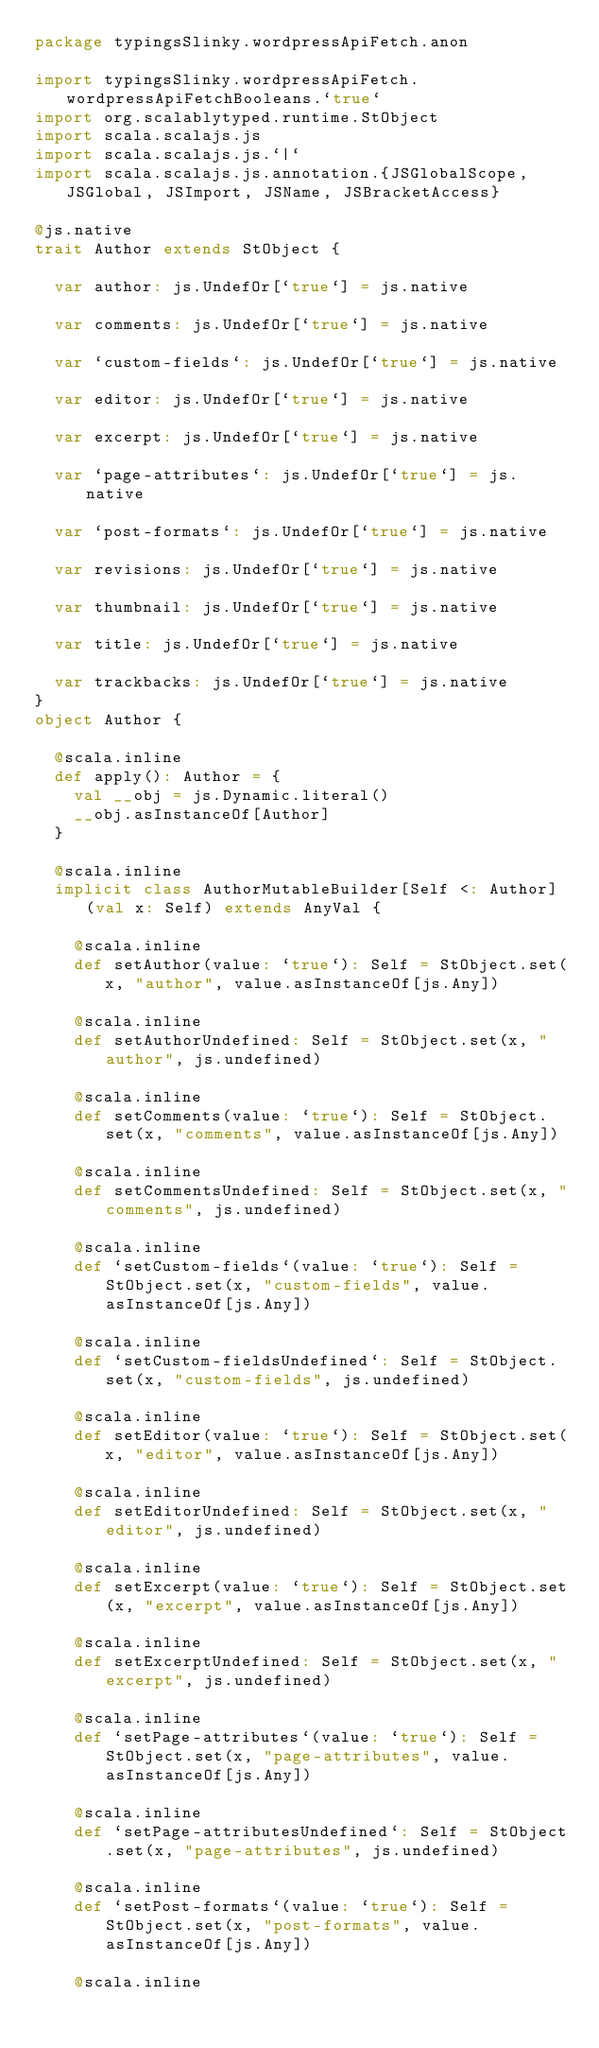<code> <loc_0><loc_0><loc_500><loc_500><_Scala_>package typingsSlinky.wordpressApiFetch.anon

import typingsSlinky.wordpressApiFetch.wordpressApiFetchBooleans.`true`
import org.scalablytyped.runtime.StObject
import scala.scalajs.js
import scala.scalajs.js.`|`
import scala.scalajs.js.annotation.{JSGlobalScope, JSGlobal, JSImport, JSName, JSBracketAccess}

@js.native
trait Author extends StObject {
  
  var author: js.UndefOr[`true`] = js.native
  
  var comments: js.UndefOr[`true`] = js.native
  
  var `custom-fields`: js.UndefOr[`true`] = js.native
  
  var editor: js.UndefOr[`true`] = js.native
  
  var excerpt: js.UndefOr[`true`] = js.native
  
  var `page-attributes`: js.UndefOr[`true`] = js.native
  
  var `post-formats`: js.UndefOr[`true`] = js.native
  
  var revisions: js.UndefOr[`true`] = js.native
  
  var thumbnail: js.UndefOr[`true`] = js.native
  
  var title: js.UndefOr[`true`] = js.native
  
  var trackbacks: js.UndefOr[`true`] = js.native
}
object Author {
  
  @scala.inline
  def apply(): Author = {
    val __obj = js.Dynamic.literal()
    __obj.asInstanceOf[Author]
  }
  
  @scala.inline
  implicit class AuthorMutableBuilder[Self <: Author] (val x: Self) extends AnyVal {
    
    @scala.inline
    def setAuthor(value: `true`): Self = StObject.set(x, "author", value.asInstanceOf[js.Any])
    
    @scala.inline
    def setAuthorUndefined: Self = StObject.set(x, "author", js.undefined)
    
    @scala.inline
    def setComments(value: `true`): Self = StObject.set(x, "comments", value.asInstanceOf[js.Any])
    
    @scala.inline
    def setCommentsUndefined: Self = StObject.set(x, "comments", js.undefined)
    
    @scala.inline
    def `setCustom-fields`(value: `true`): Self = StObject.set(x, "custom-fields", value.asInstanceOf[js.Any])
    
    @scala.inline
    def `setCustom-fieldsUndefined`: Self = StObject.set(x, "custom-fields", js.undefined)
    
    @scala.inline
    def setEditor(value: `true`): Self = StObject.set(x, "editor", value.asInstanceOf[js.Any])
    
    @scala.inline
    def setEditorUndefined: Self = StObject.set(x, "editor", js.undefined)
    
    @scala.inline
    def setExcerpt(value: `true`): Self = StObject.set(x, "excerpt", value.asInstanceOf[js.Any])
    
    @scala.inline
    def setExcerptUndefined: Self = StObject.set(x, "excerpt", js.undefined)
    
    @scala.inline
    def `setPage-attributes`(value: `true`): Self = StObject.set(x, "page-attributes", value.asInstanceOf[js.Any])
    
    @scala.inline
    def `setPage-attributesUndefined`: Self = StObject.set(x, "page-attributes", js.undefined)
    
    @scala.inline
    def `setPost-formats`(value: `true`): Self = StObject.set(x, "post-formats", value.asInstanceOf[js.Any])
    
    @scala.inline</code> 